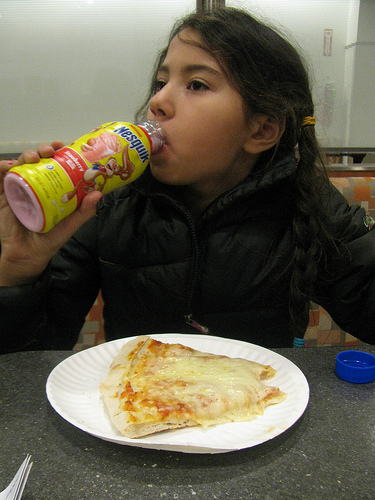<image>
Is the food on the table? Yes. Looking at the image, I can see the food is positioned on top of the table, with the table providing support. Is there a girl on the juice bottle? No. The girl is not positioned on the juice bottle. They may be near each other, but the girl is not supported by or resting on top of the juice bottle. 